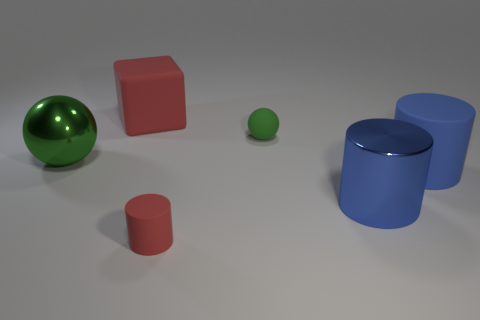Add 1 green rubber spheres. How many objects exist? 7 Subtract all spheres. How many objects are left? 4 Subtract all metal balls. Subtract all large blue rubber cylinders. How many objects are left? 4 Add 5 big green objects. How many big green objects are left? 6 Add 3 small red rubber things. How many small red rubber things exist? 4 Subtract 0 brown spheres. How many objects are left? 6 